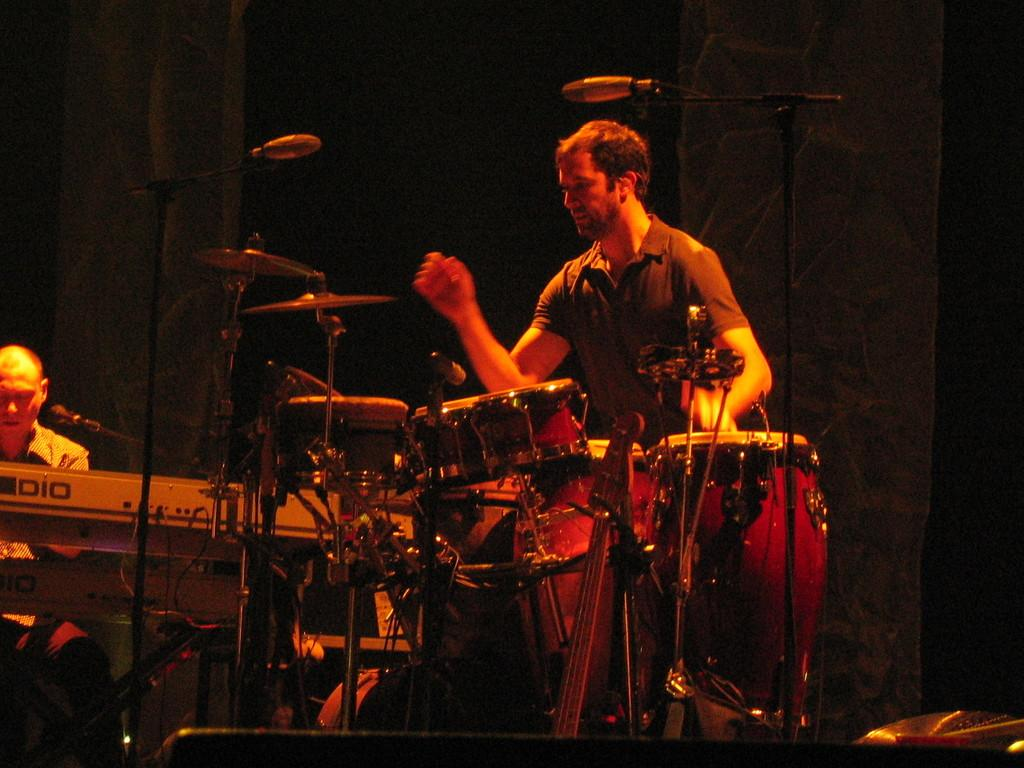How many people are in the image? There are two people in the image. What are the two people doing in the image? The two people are playing musical instruments. What type of pet can be seen playing with a hat in the image? There is no pet or hat present in the image; it features two people playing musical instruments. 